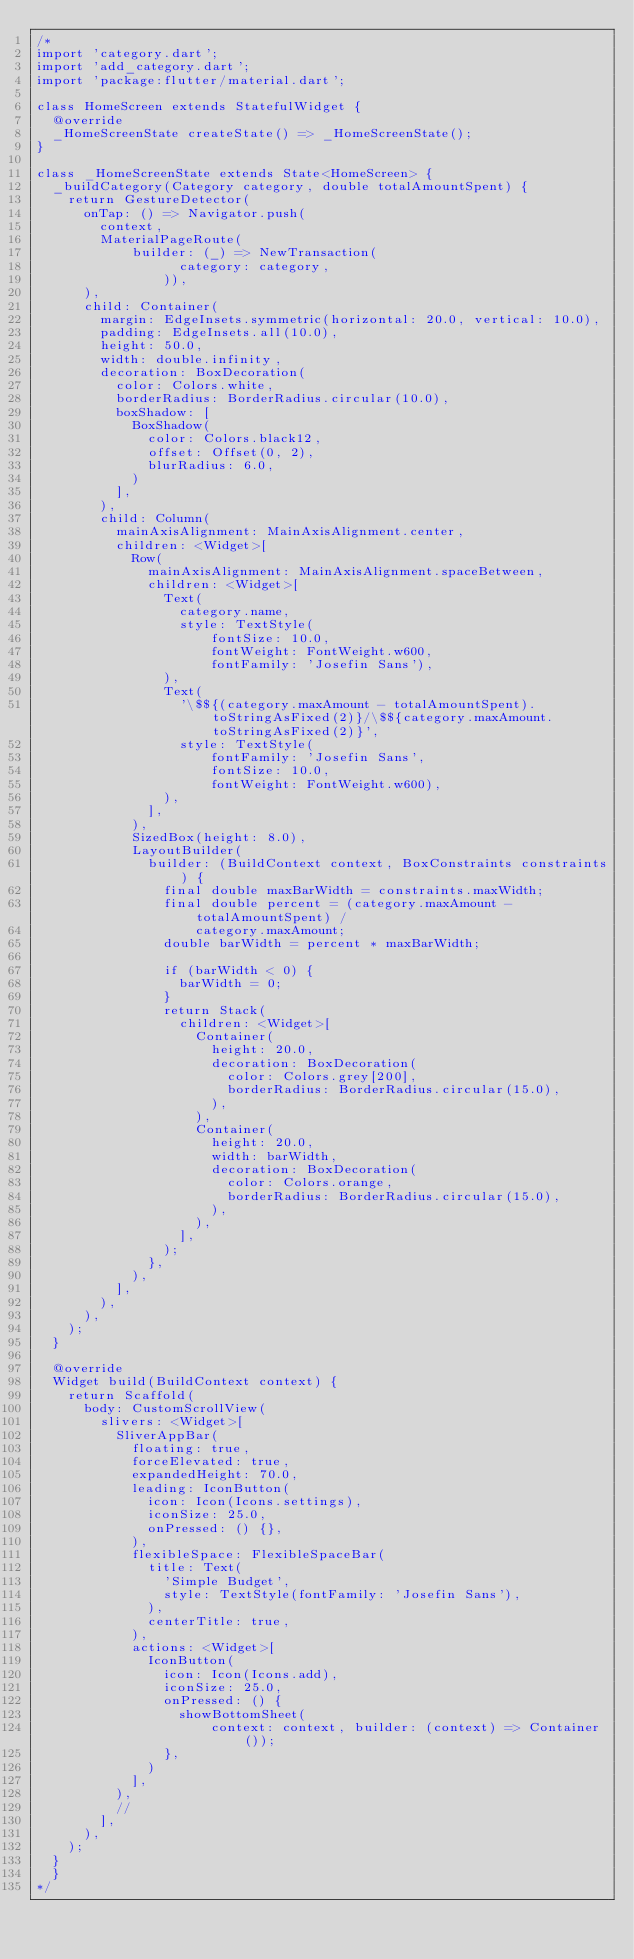<code> <loc_0><loc_0><loc_500><loc_500><_Dart_>/*
import 'category.dart';
import 'add_category.dart';
import 'package:flutter/material.dart';

class HomeScreen extends StatefulWidget {
  @override
  _HomeScreenState createState() => _HomeScreenState();
}

class _HomeScreenState extends State<HomeScreen> {
  _buildCategory(Category category, double totalAmountSpent) {
    return GestureDetector(
      onTap: () => Navigator.push(
        context,
        MaterialPageRoute(
            builder: (_) => NewTransaction(
                  category: category,
                )),
      ),
      child: Container(
        margin: EdgeInsets.symmetric(horizontal: 20.0, vertical: 10.0),
        padding: EdgeInsets.all(10.0),
        height: 50.0,
        width: double.infinity,
        decoration: BoxDecoration(
          color: Colors.white,
          borderRadius: BorderRadius.circular(10.0),
          boxShadow: [
            BoxShadow(
              color: Colors.black12,
              offset: Offset(0, 2),
              blurRadius: 6.0,
            )
          ],
        ),
        child: Column(
          mainAxisAlignment: MainAxisAlignment.center,
          children: <Widget>[
            Row(
              mainAxisAlignment: MainAxisAlignment.spaceBetween,
              children: <Widget>[
                Text(
                  category.name,
                  style: TextStyle(
                      fontSize: 10.0,
                      fontWeight: FontWeight.w600,
                      fontFamily: 'Josefin Sans'),
                ),
                Text(
                  '\$${(category.maxAmount - totalAmountSpent).toStringAsFixed(2)}/\$${category.maxAmount.toStringAsFixed(2)}',
                  style: TextStyle(
                      fontFamily: 'Josefin Sans',
                      fontSize: 10.0,
                      fontWeight: FontWeight.w600),
                ),
              ],
            ),
            SizedBox(height: 8.0),
            LayoutBuilder(
              builder: (BuildContext context, BoxConstraints constraints) {
                final double maxBarWidth = constraints.maxWidth;
                final double percent = (category.maxAmount - totalAmountSpent) /
                    category.maxAmount;
                double barWidth = percent * maxBarWidth;

                if (barWidth < 0) {
                  barWidth = 0;
                }
                return Stack(
                  children: <Widget>[
                    Container(
                      height: 20.0,
                      decoration: BoxDecoration(
                        color: Colors.grey[200],
                        borderRadius: BorderRadius.circular(15.0),
                      ),
                    ),
                    Container(
                      height: 20.0,
                      width: barWidth,
                      decoration: BoxDecoration(
                        color: Colors.orange,
                        borderRadius: BorderRadius.circular(15.0),
                      ),
                    ),
                  ],
                );
              },
            ),
          ],
        ),
      ),
    );
  }

  @override
  Widget build(BuildContext context) {
    return Scaffold(
      body: CustomScrollView(
        slivers: <Widget>[
          SliverAppBar(
            floating: true,
            forceElevated: true,
            expandedHeight: 70.0,
            leading: IconButton(
              icon: Icon(Icons.settings),
              iconSize: 25.0,
              onPressed: () {},
            ),
            flexibleSpace: FlexibleSpaceBar(
              title: Text(
                'Simple Budget',
                style: TextStyle(fontFamily: 'Josefin Sans'),
              ),
              centerTitle: true,
            ),
            actions: <Widget>[
              IconButton(
                icon: Icon(Icons.add),
                iconSize: 25.0,
                onPressed: () {
                  showBottomSheet(
                      context: context, builder: (context) => Container());
                },
              )
            ],
          ),
          // 
        ],
      ),
    );
  }
  }
*/
</code> 